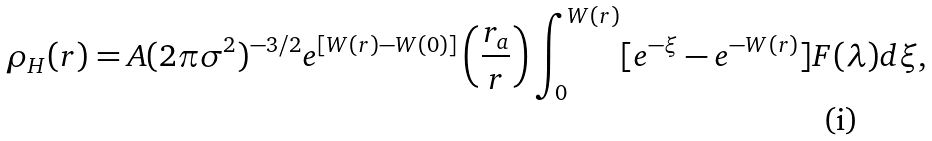Convert formula to latex. <formula><loc_0><loc_0><loc_500><loc_500>\rho _ { H } ( r ) = A ( 2 \pi \sigma ^ { 2 } ) ^ { - 3 / 2 } e ^ { [ W ( r ) - W ( 0 ) ] } \left ( \frac { r _ { a } } { r } \right ) \int _ { 0 } ^ { W ( r ) } [ e ^ { - \xi } - e ^ { - W ( r ) } ] F ( \lambda ) d \xi ,</formula> 